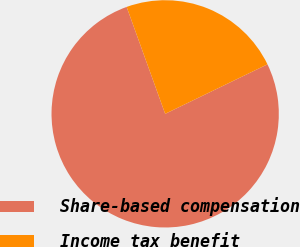Convert chart to OTSL. <chart><loc_0><loc_0><loc_500><loc_500><pie_chart><fcel>Share-based compensation<fcel>Income tax benefit<nl><fcel>76.67%<fcel>23.33%<nl></chart> 